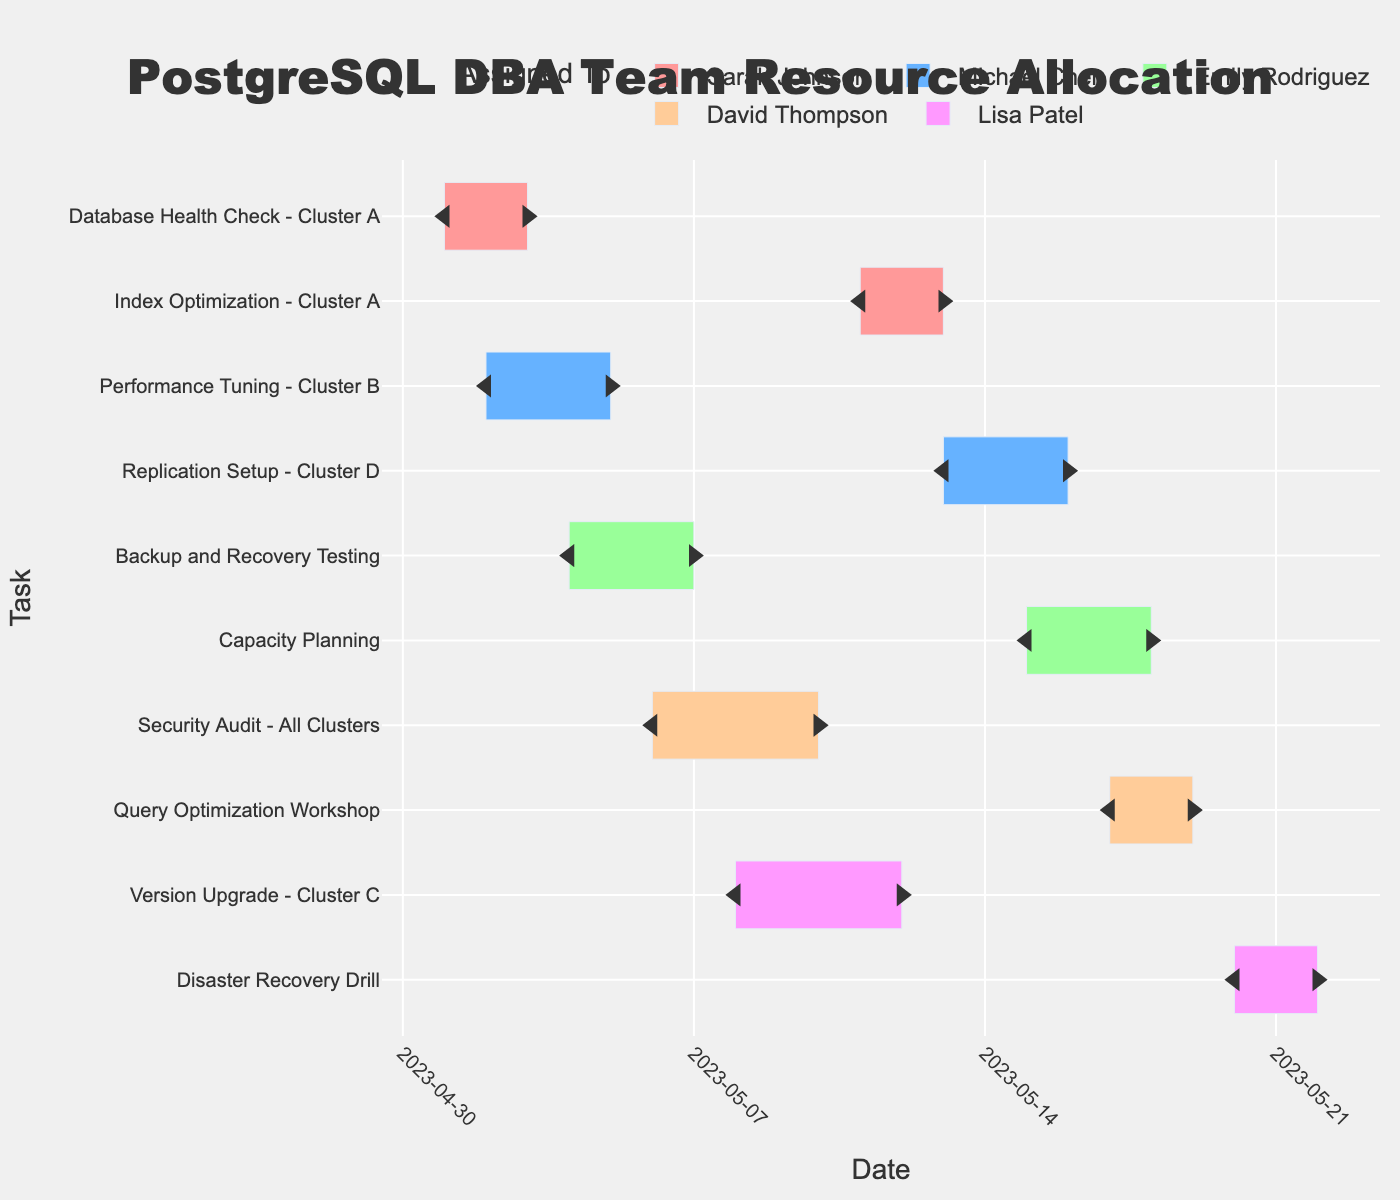What is the title of the Gantt chart? The title of the Gantt chart is usually prominently displayed at the top center of the chart. Here, it reads "PostgreSQL DBA Team Resource Allocation".
Answer: PostgreSQL DBA Team Resource Allocation Who is assigned to perform the Database Health Check for Cluster A? Tasks and their assigned personnel are listed in the chart. For "Database Health Check - Cluster A," the assigned person is Sarah Johnson.
Answer: Sarah Johnson Which task has the longest duration? The duration of each task can be found by looking at the end of the bars. The "Security Audit - All Clusters" task spans from May 6 to May 10, which is a total of 5 days, making it the longest task.
Answer: Security Audit - All Clusters How many days is the Performance Tuning for Cluster B scheduled to take? The task "Performance Tuning - Cluster B" starts on May 2 and ends on May 5. This duration is calculated as (May 5 - May 2) = 3 days.
Answer: 3 days Which DBA has the most tasks assigned? By counting the number of tasks assigned to each DBA, we see that Sarah Johnson and Michael Chen each have 2 tasks, whereas others have fewer. Therefore, they have the most tasks assigned.
Answer: Sarah Johnson, Michael Chen On which date is the Capacity Planning task scheduled to start? The "Capacity Planning" task starts on May 15, as indicated in the Gantt chart.
Answer: May 15 Which two tasks are assigned to Emily Rodriguez? The tasks listed under Emily Rodriguez are "Backup and Recovery Testing" and "Capacity Planning". They can be identified by checking the "Assigned To" labels associated with her name.
Answer: Backup and Recovery Testing, Capacity Planning Are there any tasks assigned to David Thompson in the last week of May? No tasks are assigned to David Thompson in the last week of May. His tasks "Security Audit - All Clusters" and "Query Optimization Workshop" are both scheduled before May 20.
Answer: No How many tasks are scheduled to end on May 13? Checking the end dates in the chart, only "Index Optimization - Cluster A" ends on May 13.
Answer: 1 Which task occurs immediately after the Version Upgrade for Cluster C? Following the "Version Upgrade - Cluster C" which ends on May 12, the next task is "Index Optimization - Cluster A" starting on May 11.
Answer: Index Optimization - Cluster A 